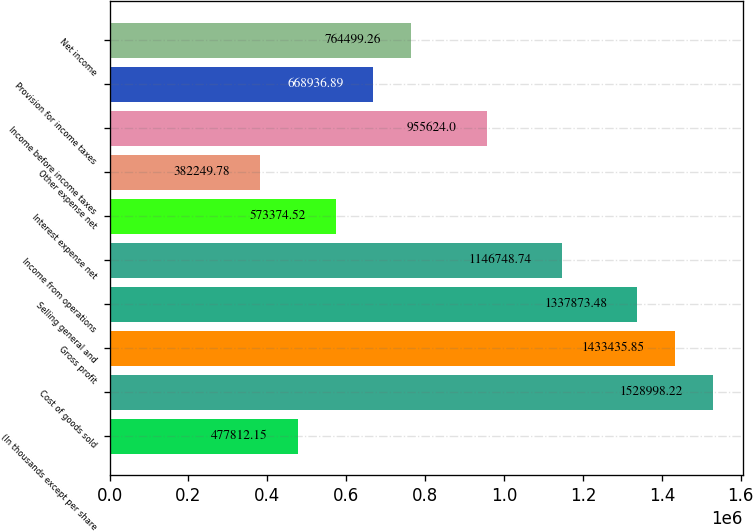Convert chart to OTSL. <chart><loc_0><loc_0><loc_500><loc_500><bar_chart><fcel>(In thousands except per share<fcel>Cost of goods sold<fcel>Gross profit<fcel>Selling general and<fcel>Income from operations<fcel>Interest expense net<fcel>Other expense net<fcel>Income before income taxes<fcel>Provision for income taxes<fcel>Net income<nl><fcel>477812<fcel>1.529e+06<fcel>1.43344e+06<fcel>1.33787e+06<fcel>1.14675e+06<fcel>573375<fcel>382250<fcel>955624<fcel>668937<fcel>764499<nl></chart> 